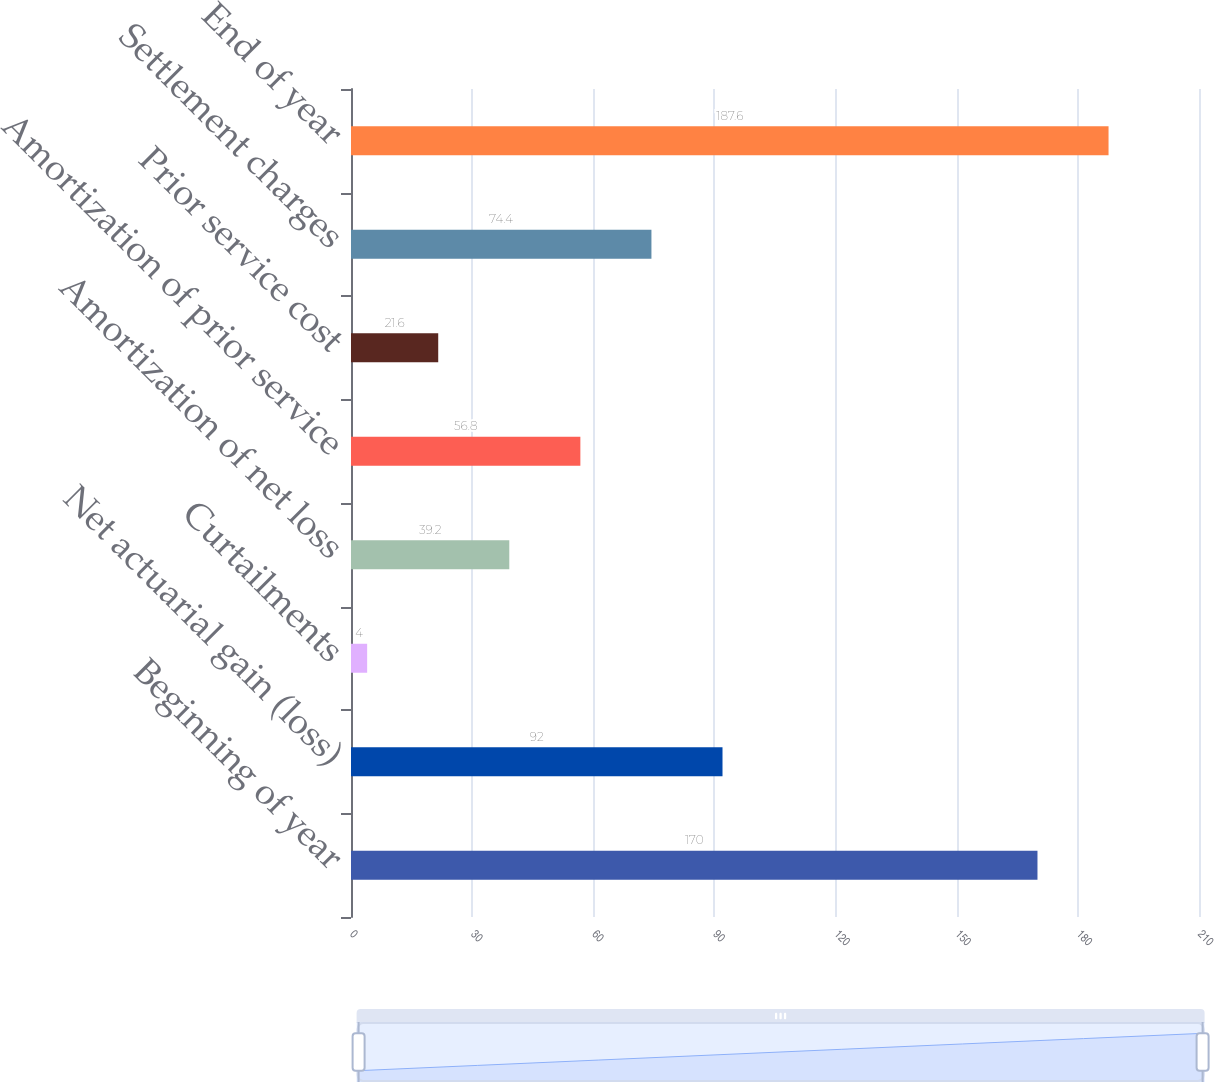<chart> <loc_0><loc_0><loc_500><loc_500><bar_chart><fcel>Beginning of year<fcel>Net actuarial gain (loss)<fcel>Curtailments<fcel>Amortization of net loss<fcel>Amortization of prior service<fcel>Prior service cost<fcel>Settlement charges<fcel>End of year<nl><fcel>170<fcel>92<fcel>4<fcel>39.2<fcel>56.8<fcel>21.6<fcel>74.4<fcel>187.6<nl></chart> 